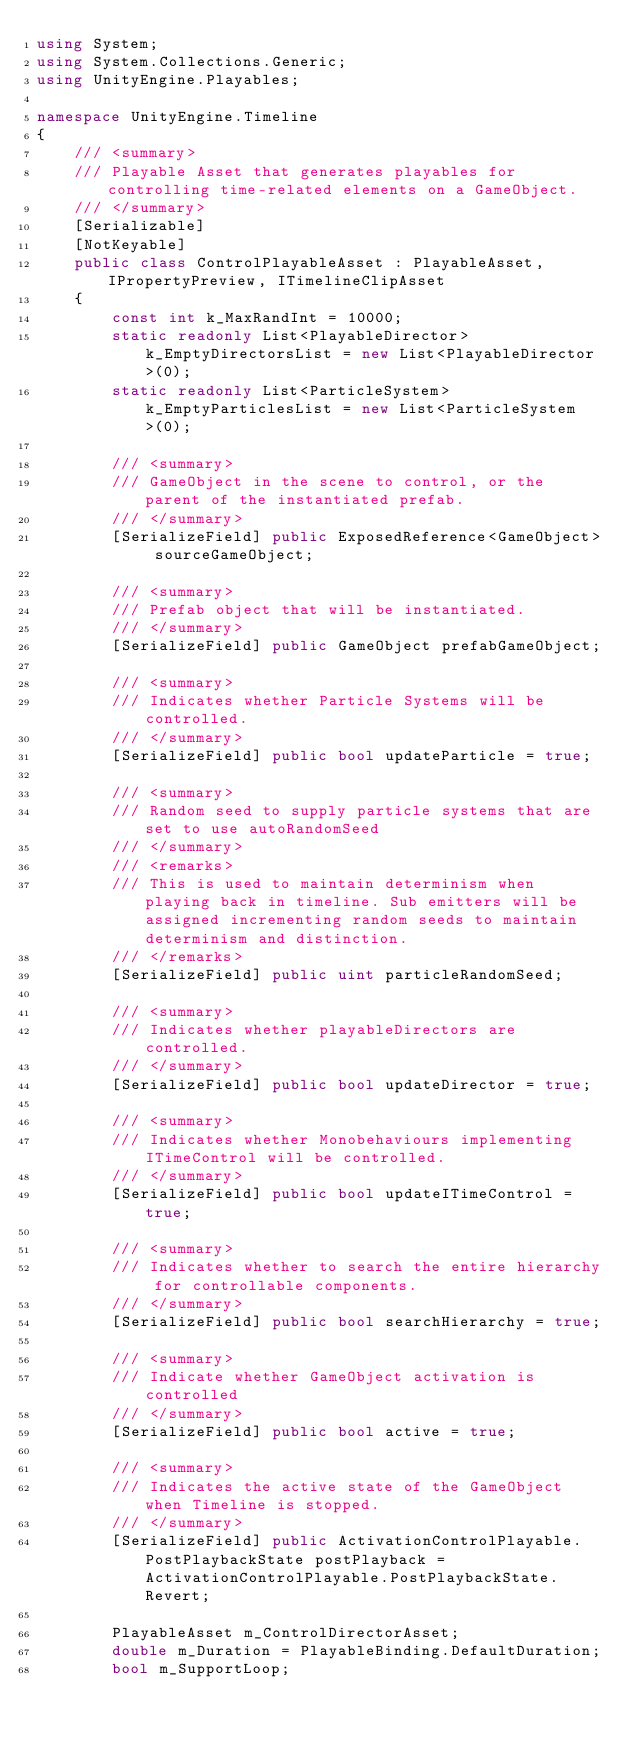<code> <loc_0><loc_0><loc_500><loc_500><_C#_>using System;
using System.Collections.Generic;
using UnityEngine.Playables;

namespace UnityEngine.Timeline
{
    /// <summary>
    /// Playable Asset that generates playables for controlling time-related elements on a GameObject.
    /// </summary>
    [Serializable]
    [NotKeyable]
    public class ControlPlayableAsset : PlayableAsset, IPropertyPreview, ITimelineClipAsset
    {
        const int k_MaxRandInt = 10000;
        static readonly List<PlayableDirector> k_EmptyDirectorsList = new List<PlayableDirector>(0);
        static readonly List<ParticleSystem> k_EmptyParticlesList = new List<ParticleSystem>(0);

        /// <summary>
        /// GameObject in the scene to control, or the parent of the instantiated prefab.
        /// </summary>
        [SerializeField] public ExposedReference<GameObject> sourceGameObject;

        /// <summary>
        /// Prefab object that will be instantiated.
        /// </summary>
        [SerializeField] public GameObject prefabGameObject;

        /// <summary>
        /// Indicates whether Particle Systems will be controlled.
        /// </summary>
        [SerializeField] public bool updateParticle = true;

        /// <summary>
        /// Random seed to supply particle systems that are set to use autoRandomSeed
        /// </summary>
        /// <remarks>
        /// This is used to maintain determinism when playing back in timeline. Sub emitters will be assigned incrementing random seeds to maintain determinism and distinction.
        /// </remarks>
        [SerializeField] public uint particleRandomSeed;

        /// <summary>
        /// Indicates whether playableDirectors are controlled.
        /// </summary>
        [SerializeField] public bool updateDirector = true;

        /// <summary>
        /// Indicates whether Monobehaviours implementing ITimeControl will be controlled.
        /// </summary>
        [SerializeField] public bool updateITimeControl = true;

        /// <summary>
        /// Indicates whether to search the entire hierarchy for controllable components.
        /// </summary>
        [SerializeField] public bool searchHierarchy = true;

        /// <summary>
        /// Indicate whether GameObject activation is controlled
        /// </summary>
        [SerializeField] public bool active = true;

        /// <summary>
        /// Indicates the active state of the GameObject when Timeline is stopped.
        /// </summary>
        [SerializeField] public ActivationControlPlayable.PostPlaybackState postPlayback = ActivationControlPlayable.PostPlaybackState.Revert;

        PlayableAsset m_ControlDirectorAsset;
        double m_Duration = PlayableBinding.DefaultDuration;
        bool m_SupportLoop;
</code> 